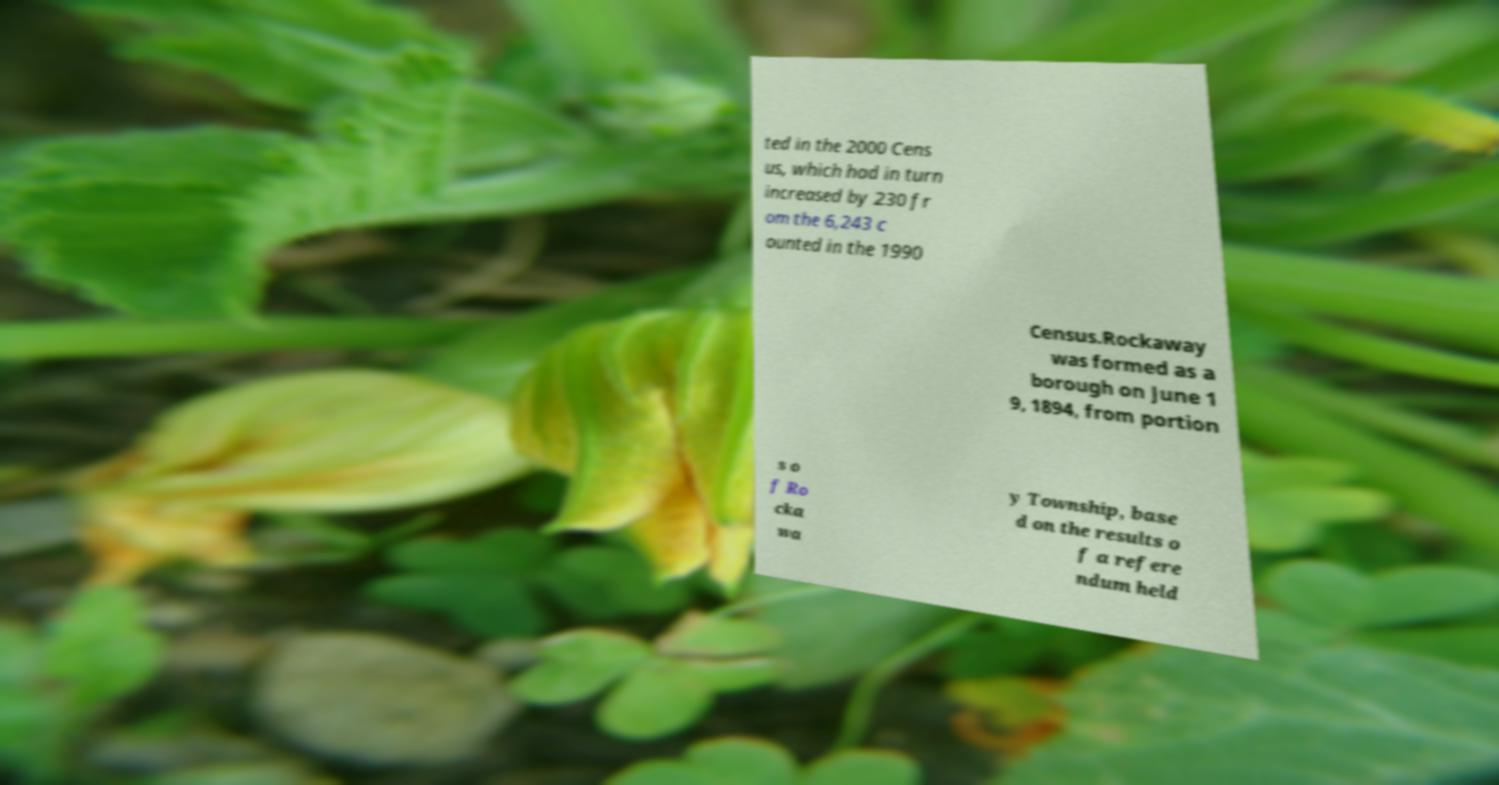For documentation purposes, I need the text within this image transcribed. Could you provide that? ted in the 2000 Cens us, which had in turn increased by 230 fr om the 6,243 c ounted in the 1990 Census.Rockaway was formed as a borough on June 1 9, 1894, from portion s o f Ro cka wa y Township, base d on the results o f a refere ndum held 